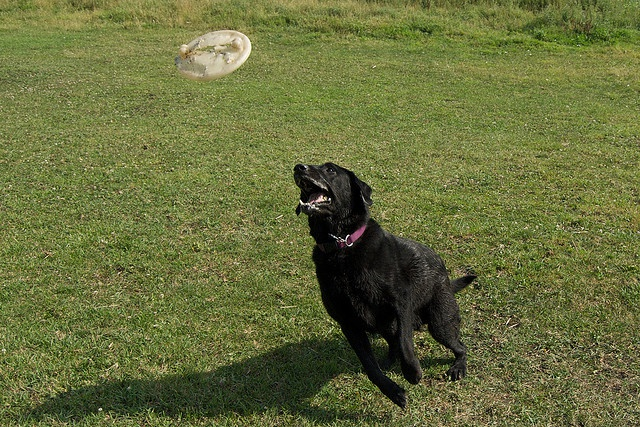Describe the objects in this image and their specific colors. I can see dog in olive, black, gray, and darkgreen tones and frisbee in olive and tan tones in this image. 